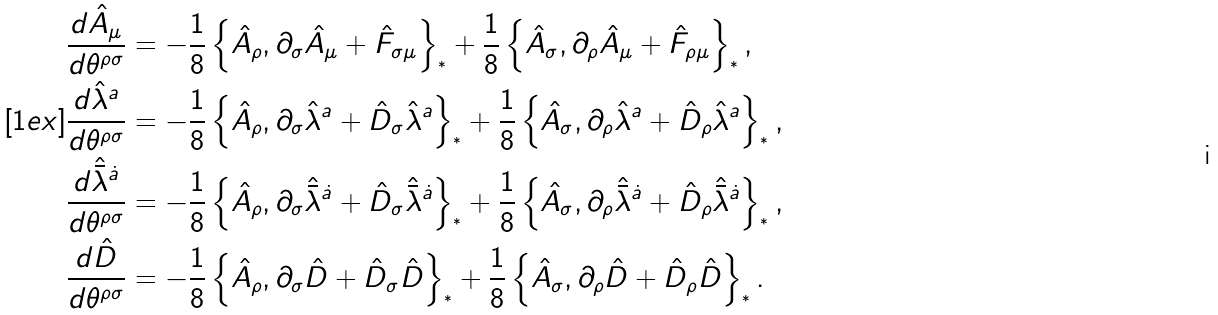<formula> <loc_0><loc_0><loc_500><loc_500>\frac { d \hat { A } _ { \mu } } { d \theta ^ { \rho \sigma } } & = - \frac { 1 } { 8 } \left \{ \hat { A } _ { \rho } , \partial _ { \sigma } \hat { A } _ { \mu } + \hat { F } _ { \sigma \mu } \right \} _ { ^ { * } } + \frac { 1 } { 8 } \left \{ \hat { A } _ { \sigma } , \partial _ { \rho } \hat { A } _ { \mu } + \hat { F } _ { \rho \mu } \right \} _ { ^ { * } } , \\ [ 1 e x ] \frac { d \hat { \lambda } ^ { a } } { d \theta ^ { \rho \sigma } } & = - \frac { 1 } { 8 } \left \{ \hat { A } _ { \rho } , \partial _ { \sigma } \hat { \lambda } ^ { a } + \hat { D } _ { \sigma } \hat { \lambda } ^ { a } \right \} _ { ^ { * } } + \frac { 1 } { 8 } \left \{ \hat { A } _ { \sigma } , \partial _ { \rho } \hat { \lambda } ^ { a } + \hat { D } _ { \rho } \hat { \lambda } ^ { a } \right \} _ { ^ { * } } , \\ \frac { d \hat { \bar { \lambda } } ^ { \dot { a } } } { d \theta ^ { \rho \sigma } } & = - \frac { 1 } { 8 } \left \{ \hat { A } _ { \rho } , \partial _ { \sigma } \hat { \bar { \lambda } } ^ { \dot { a } } + \hat { D } _ { \sigma } \hat { \bar { \lambda } } ^ { \dot { a } } \right \} _ { ^ { * } } + \frac { 1 } { 8 } \left \{ \hat { A } _ { \sigma } , \partial _ { \rho } \hat { \bar { \lambda } } ^ { \dot { a } } + \hat { D } _ { \rho } \hat { \bar { \lambda } } ^ { \dot { a } } \right \} _ { ^ { * } } , \\ \frac { d \hat { D } } { d \theta ^ { \rho \sigma } } & = - \frac { 1 } { 8 } \left \{ \hat { A } _ { \rho } , \partial _ { \sigma } \hat { D } + \hat { D } _ { \sigma } \hat { D } \right \} _ { ^ { * } } + \frac { 1 } { 8 } \left \{ \hat { A } _ { \sigma } , \partial _ { \rho } \hat { D } + \hat { D } _ { \rho } \hat { D } \right \} _ { ^ { * } } .</formula> 